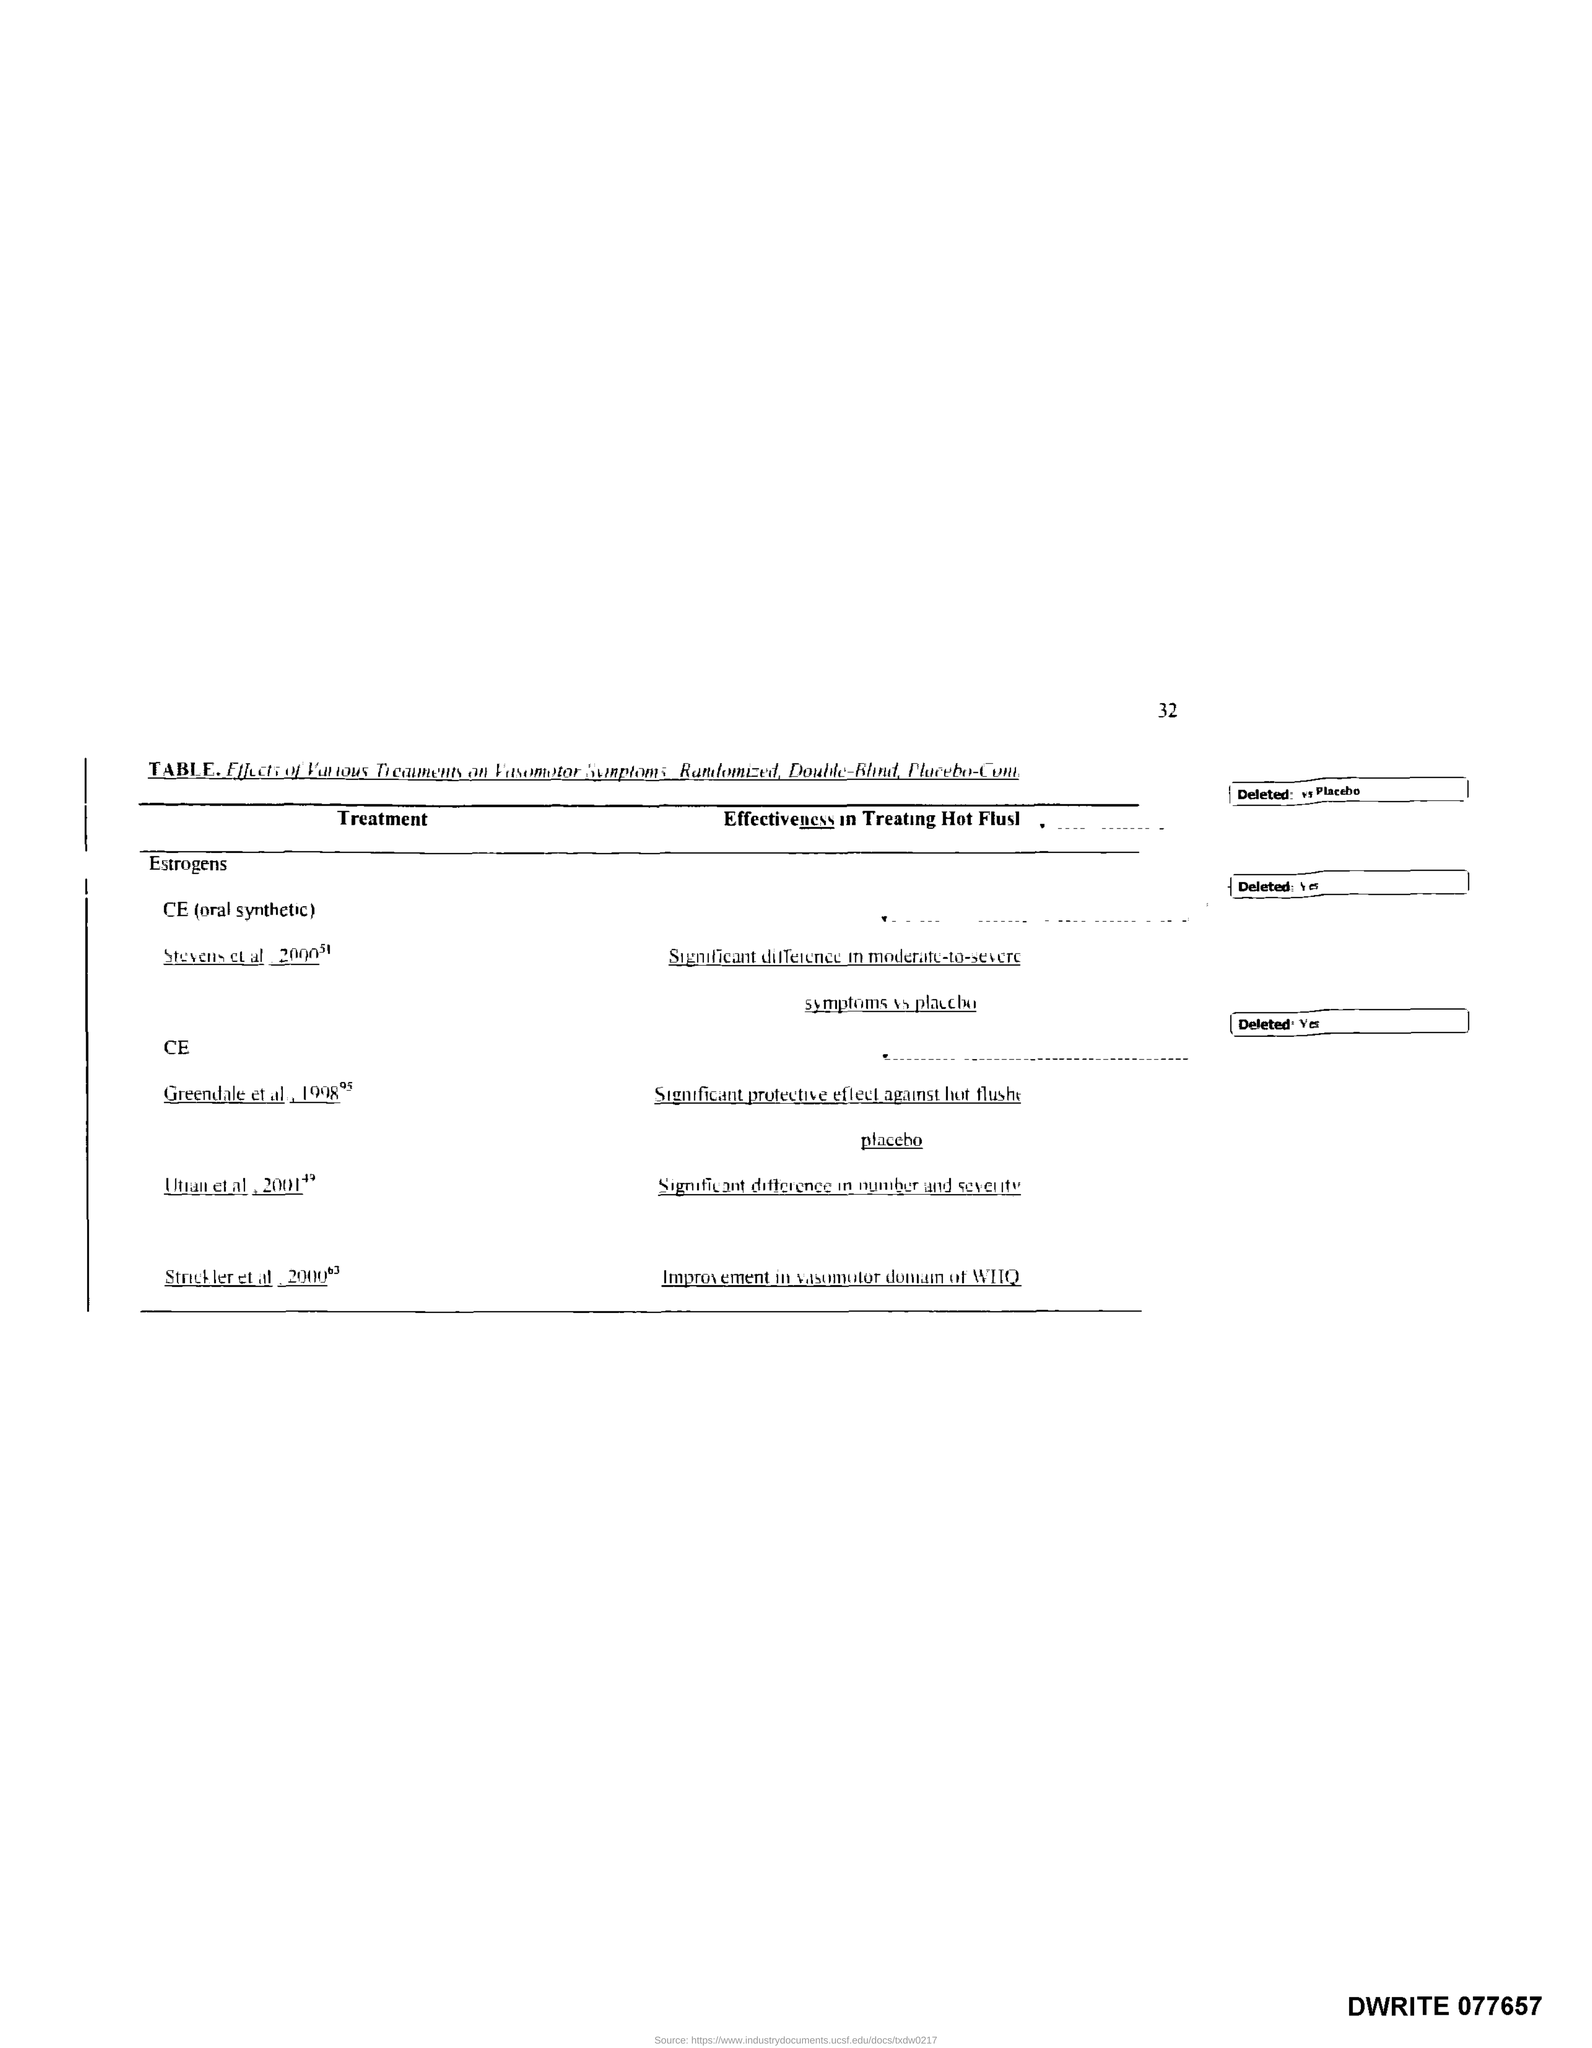Highlight a few significant elements in this photo. The page number is 32. 